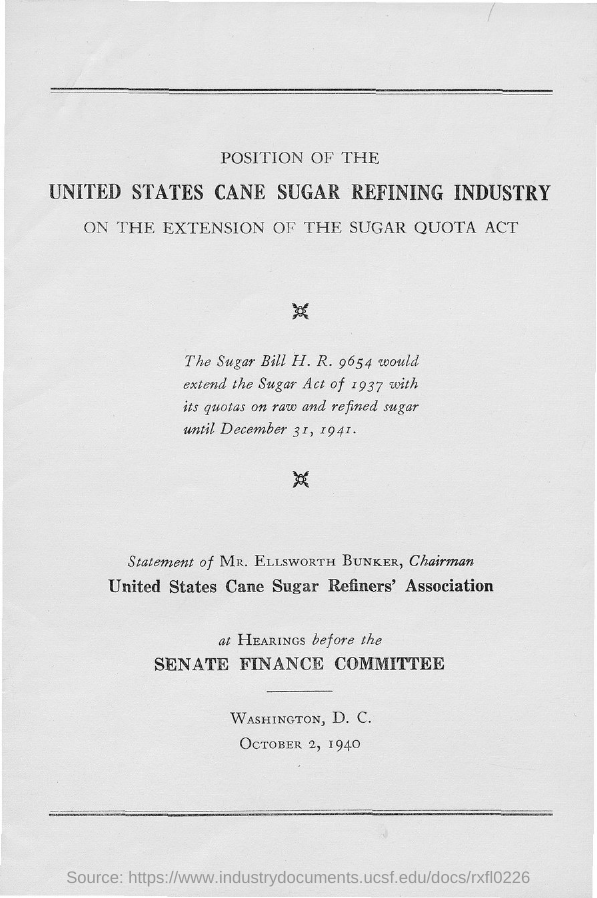Give some essential details in this illustration. The United States Cane Sugar Refiners' Association has a chairman named Mr. Ellsworth Bunker. The Sugar Bill H.R. 9654 is extended by the Sugar Act of 1937. 